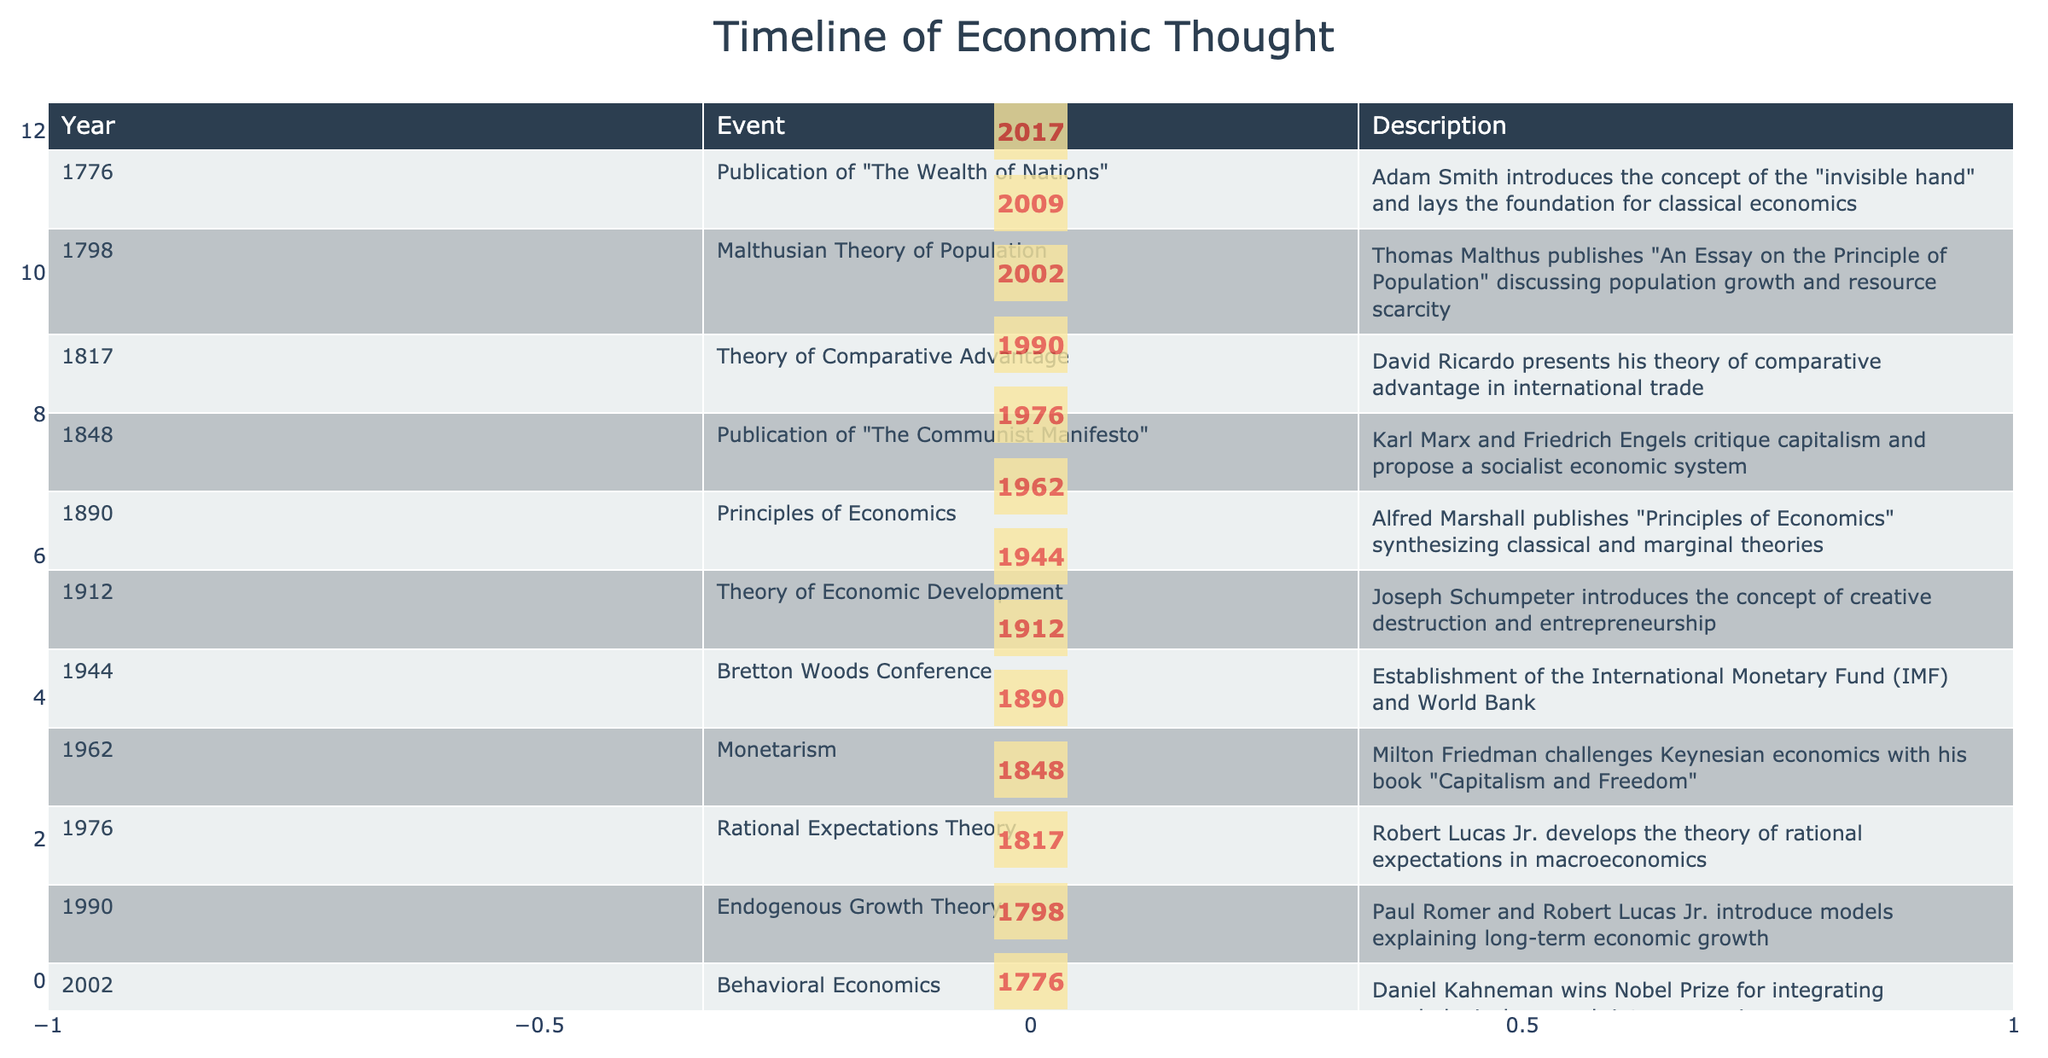What year was "The Wealth of Nations" published? The table lists the publication year for "The Wealth of Nations" as 1776 under the Event column.
Answer: 1776 Who introduced the concept of the "invisible hand"? The table indicates that Adam Smith, associated with the publication of "The Wealth of Nations" in 1776, introduced the concept of the "invisible hand."
Answer: Adam Smith Which two economists published their work on the same year, 1848? The table shows that both Karl Marx and Friedrich Engels published "The Communist Manifesto" in 1848.
Answer: Karl Marx and Friedrich Engels Is the Theory of Rational Expectations older than the Bretton Woods Conference? The table provides that the Bretton Woods Conference occurred in 1944 and the Theory of Rational Expectations was developed in 1976, making the conference older.
Answer: Yes What is the difference in years between the publication of "Principles of Economics" and the introduction of Behavioral Economics? The publication of "Principles of Economics" appears in 1890 and Behavioral Economics in 2002. Calculating the difference: 2002 - 1890 equals 112 years.
Answer: 112 years List the last economist mentioned in the timeline and their significant achievement. The table lists Richard Thaler as the last economist in 2017 with his achievement in contributions to behavioral economics and "nudge theory."
Answer: Richard Thaler What was the primary criticism made by Karl Marx and Friedrich Engels in "The Communist Manifesto"? According to the table, the critique focused on capitalism while proposing a socialist economic system.
Answer: Critique of capitalism Which economic theory was introduced by Joseph Schumpeter and what is its core concept? The table indicates that Joseph Schumpeter introduced the Theory of Economic Development in 1912, with its core concept being creative destruction and entrepreneurship.
Answer: Creative destruction and entrepreneurship How many economists contributed to the timeline between the years 1944 and 2009? The timeline includes the Bretton Woods Conference in 1944, Milton Friedman in 1962, Robert Lucas Jr. in 1976, Paul Romer and Robert Lucas Jr. in 1990, Daniel Kahneman in 2002, and Elinor Ostrom in 2009. This accounts for five economists in total.
Answer: Five economists 